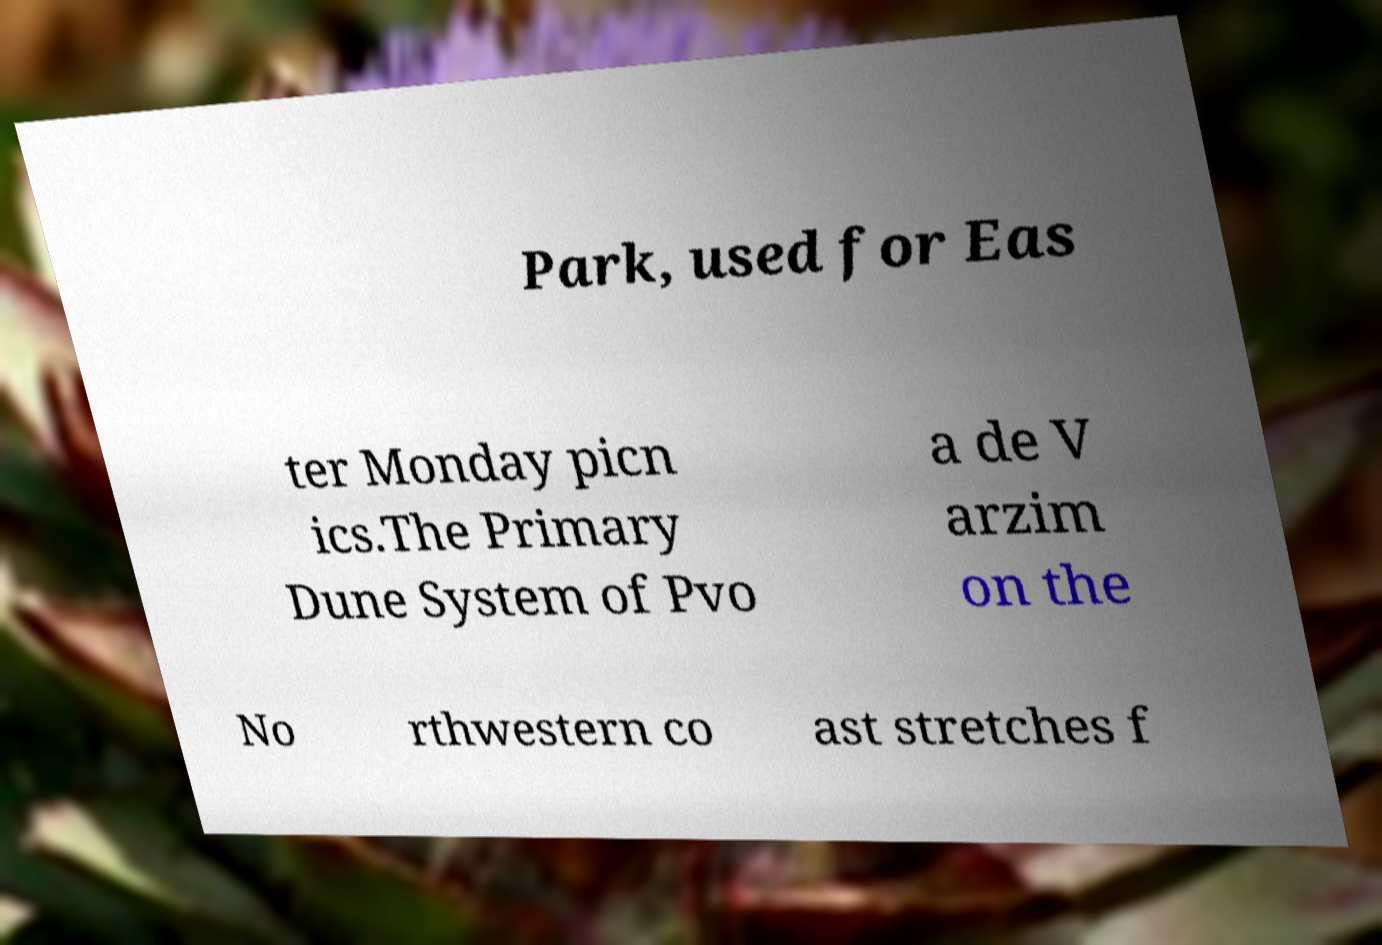Could you extract and type out the text from this image? Park, used for Eas ter Monday picn ics.The Primary Dune System of Pvo a de V arzim on the No rthwestern co ast stretches f 